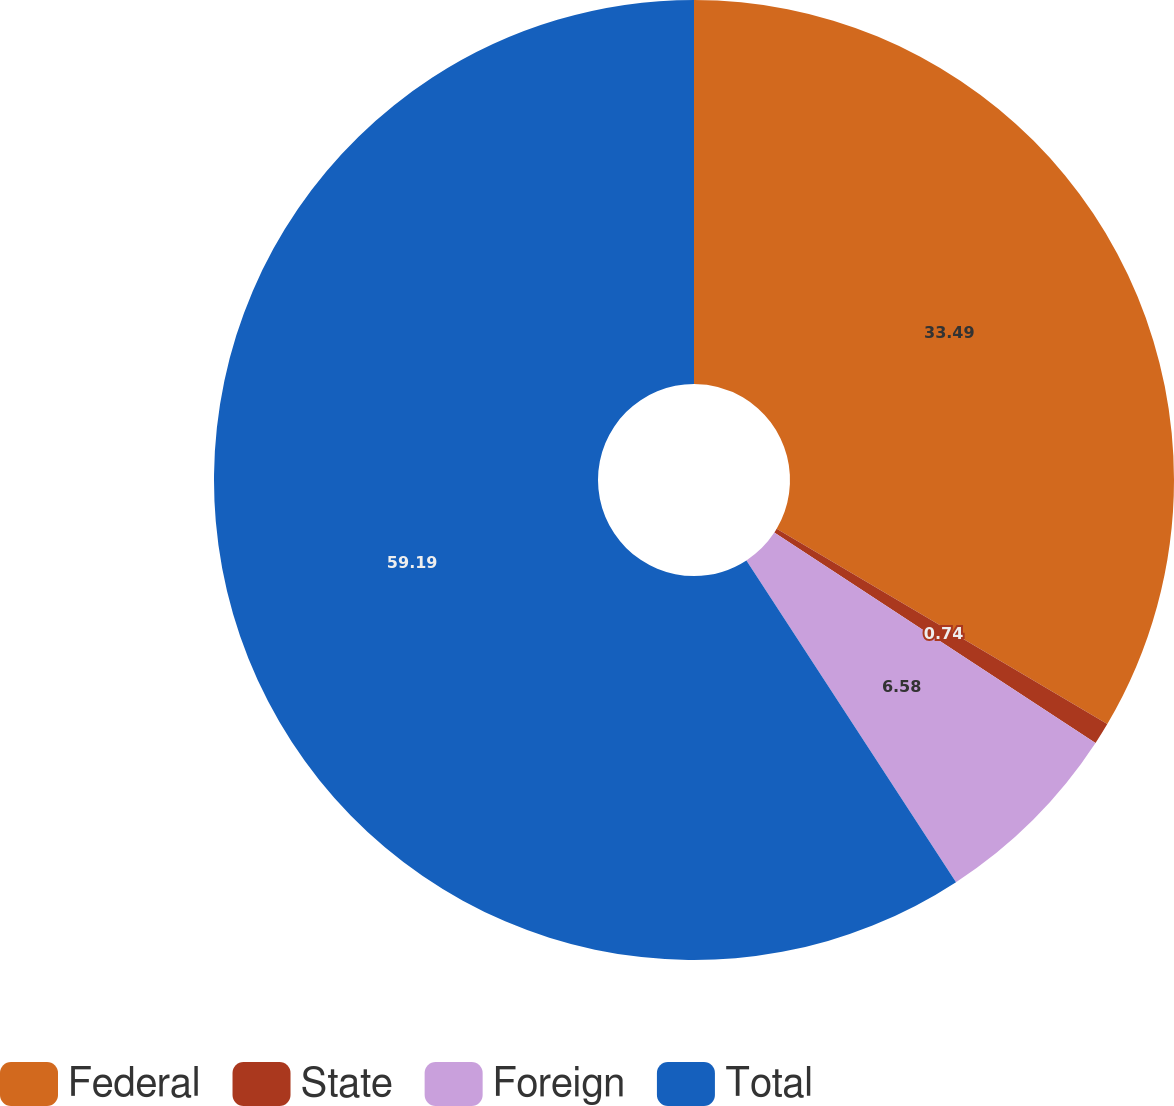Convert chart. <chart><loc_0><loc_0><loc_500><loc_500><pie_chart><fcel>Federal<fcel>State<fcel>Foreign<fcel>Total<nl><fcel>33.49%<fcel>0.74%<fcel>6.58%<fcel>59.19%<nl></chart> 